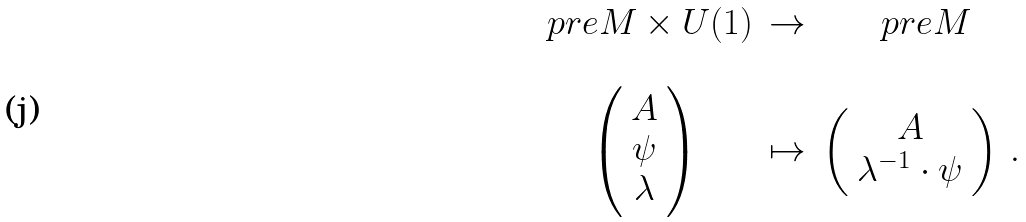Convert formula to latex. <formula><loc_0><loc_0><loc_500><loc_500>\begin{array} { c c c } \ p r e M \times U ( 1 ) & \rightarrow & \ p r e M \\ & & \\ \left ( \begin{array} { c } A \\ \psi \\ \lambda \end{array} \right ) & \mapsto & \left ( \begin{array} { c } A \\ \lambda ^ { - 1 } \cdot \psi \end{array} \right ) \, . \end{array}</formula> 